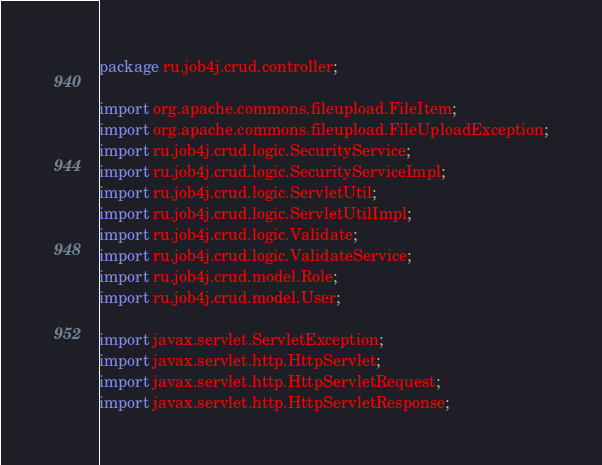<code> <loc_0><loc_0><loc_500><loc_500><_Java_>package ru.job4j.crud.controller;

import org.apache.commons.fileupload.FileItem;
import org.apache.commons.fileupload.FileUploadException;
import ru.job4j.crud.logic.SecurityService;
import ru.job4j.crud.logic.SecurityServiceImpl;
import ru.job4j.crud.logic.ServletUtil;
import ru.job4j.crud.logic.ServletUtilImpl;
import ru.job4j.crud.logic.Validate;
import ru.job4j.crud.logic.ValidateService;
import ru.job4j.crud.model.Role;
import ru.job4j.crud.model.User;

import javax.servlet.ServletException;
import javax.servlet.http.HttpServlet;
import javax.servlet.http.HttpServletRequest;
import javax.servlet.http.HttpServletResponse;</code> 